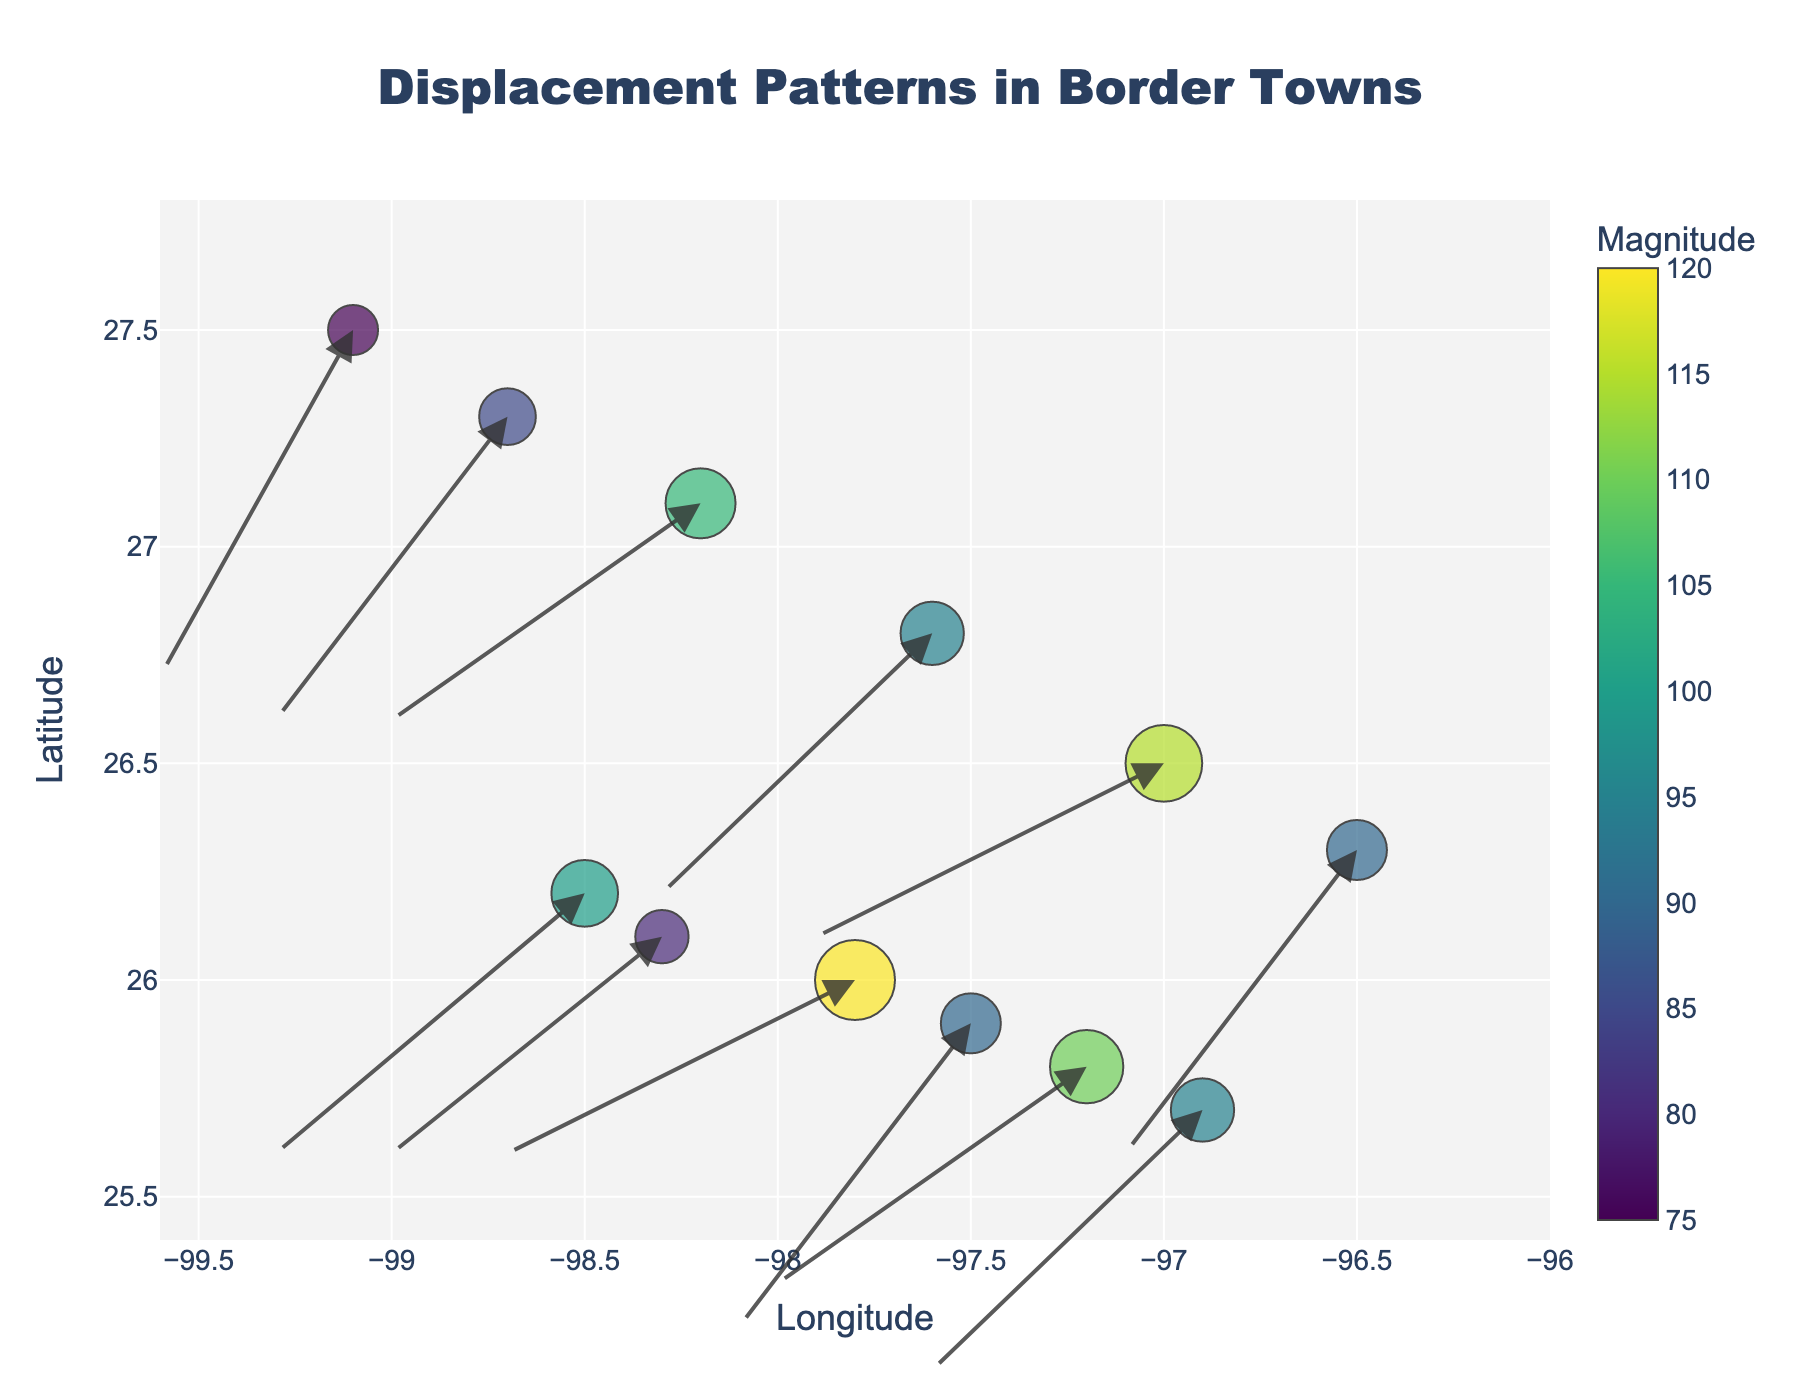What is the title of the figure? The title of a figure is typically found at the top and serves as a brief summary of what the figure represents. Looking at the top of the figure, the title is "Displacement Patterns in Border Towns".
Answer: Displacement Patterns in Border Towns What do the arrows in the figure represent? Arrows in a quiver plot generally indicate the direction and magnitude of movement or force. In this figure, the arrows represent the displacement patterns of residents in border towns, caused by cartel violence.
Answer: Displacement patterns of residents What are the units of the x-axis and y-axis? The x-axis and y-axis generally represent geographical coordinates, specifically longitude and latitude respectively. These are the standard units used for mapping locations on Earth.
Answer: Longitude and Latitude How is the magnitude of displacement visualized in the plot? The magnitude of displacement is visualized through the size and color of the circles, with a corresponding color bar indicating magnitude values. Larger circles and colors from the Viridis color scale indicate higher magnitudes.
Answer: Circle size and color Which point has the highest magnitude of displacement? To determine the point with the highest magnitude, look for the largest circle colored according to the scale. By visually inspecting the plot, the point at coordinates  -97.8, 26.0 has the largest circle and highest value of 120 as indicated in the dataset.
Answer: -97.8, 26.0 How does the direction of movement generally vary across the towns? By examining the direction of the arrows, one can assess the general flow direction of displacement. Most arrows in this plot point towards the south-west, indicating a general trend of residents moving in that direction.
Answer: Towards the south-west Compare the magnitudes of displacement for the points (-98.5, 26.2) and (-99.1, 27.5). Which one has a greater displacement? Referencing the dataset values, the magnitude for the point at (-98.5, 26.2) is 100, while that for (-99.1, 27.5) is 75. Therefore, the former has a greater displacement.
Answer: (-98.5, 26.2) What is the average magnitude of displacement across all towns? To find the average magnitude, sum all magnitude values and divide by the number of points. Sum = 100 + 80 + 120 + 90 + 110 + 95 + 75 + 85 + 105 + 95 + 115 + 90 = 1160. Number of points = 12. Average magnitude = 1160 / 12 = 96.67.
Answer: 96.67 What latitude range is covered by the towns in the dataset? The latitude range is determined by the minimum and maximum latitude values. From the dataset, the minimum latitude is 25.7 and the maximum latitude is 27.5, giving a range from 25.7 to 27.5.
Answer: 25.7 to 27.5 How can we determine if any towns have equal displacement magnitudes? By looking at the color and size of the circles and confirming with the dataset, it's evident that there are towns with the same size and color circles. For example, the points at coordinates (-97.5, 25.9) and (-96.5, 26.3) each have a magnitude of 90.
Answer: Yes, -97.5, 25.9 and -96.5, 26.3 